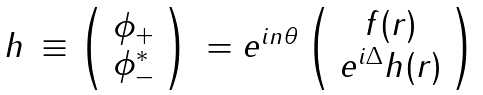Convert formula to latex. <formula><loc_0><loc_0><loc_500><loc_500>\begin{array} { c c c } h & \equiv \left ( \begin{array} { c } \phi _ { + } \\ \phi _ { - } ^ { * } \end{array} \right ) & = e ^ { i n \theta } \left ( \begin{array} { c } f ( r ) \\ e ^ { i \Delta } h ( r ) \end{array} \right ) \end{array}</formula> 